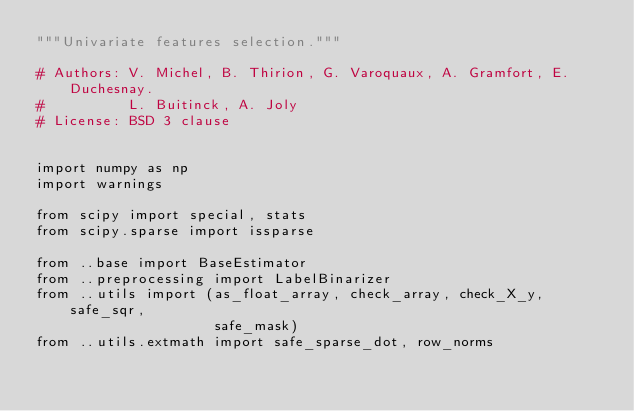Convert code to text. <code><loc_0><loc_0><loc_500><loc_500><_Python_>"""Univariate features selection."""

# Authors: V. Michel, B. Thirion, G. Varoquaux, A. Gramfort, E. Duchesnay.
#          L. Buitinck, A. Joly
# License: BSD 3 clause


import numpy as np
import warnings

from scipy import special, stats
from scipy.sparse import issparse

from ..base import BaseEstimator
from ..preprocessing import LabelBinarizer
from ..utils import (as_float_array, check_array, check_X_y, safe_sqr,
                     safe_mask)
from ..utils.extmath import safe_sparse_dot, row_norms</code> 